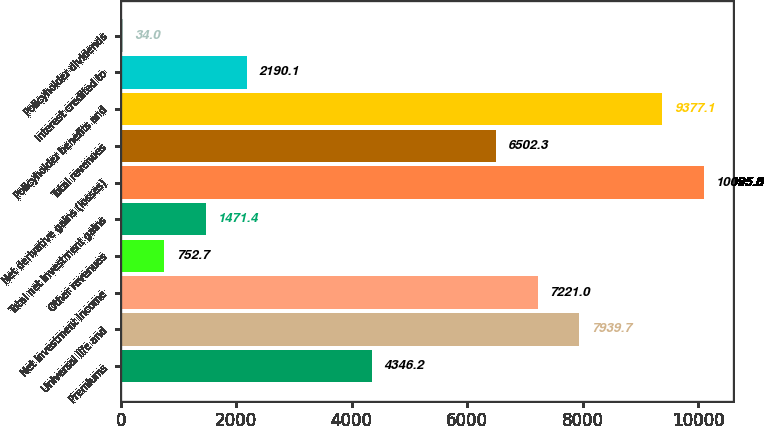<chart> <loc_0><loc_0><loc_500><loc_500><bar_chart><fcel>Premiums<fcel>Universal life and<fcel>Net investment income<fcel>Other revenues<fcel>Total net investment gains<fcel>Net derivative gains (losses)<fcel>Total revenues<fcel>Policyholder benefits and<fcel>Interest credited to<fcel>Policyholder dividends<nl><fcel>4346.2<fcel>7939.7<fcel>7221<fcel>752.7<fcel>1471.4<fcel>10095.8<fcel>6502.3<fcel>9377.1<fcel>2190.1<fcel>34<nl></chart> 